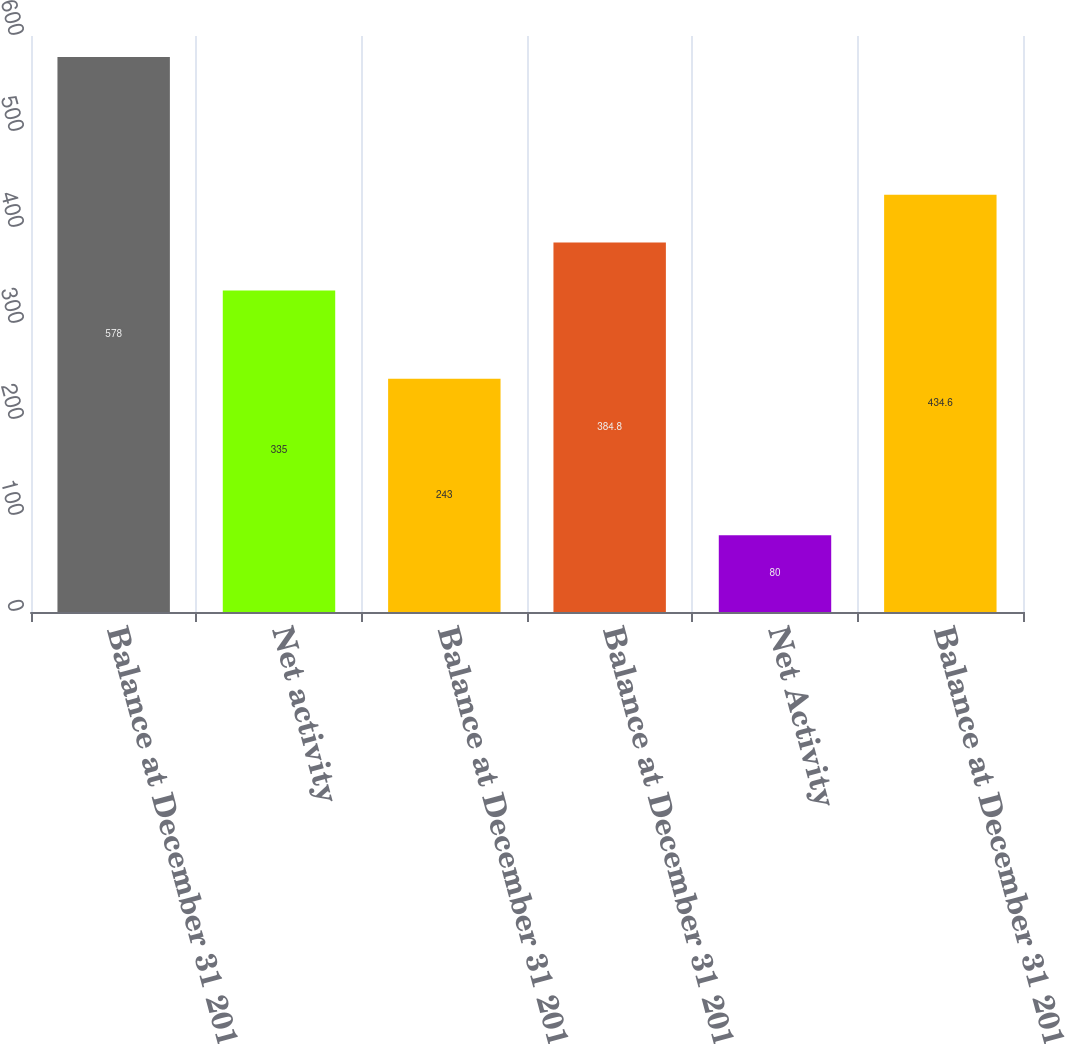<chart> <loc_0><loc_0><loc_500><loc_500><bar_chart><fcel>Balance at December 31 2012<fcel>Net activity<fcel>Balance at December 31 2013<fcel>Balance at December 31 2014<fcel>Net Activity<fcel>Balance at December 31 2015<nl><fcel>578<fcel>335<fcel>243<fcel>384.8<fcel>80<fcel>434.6<nl></chart> 